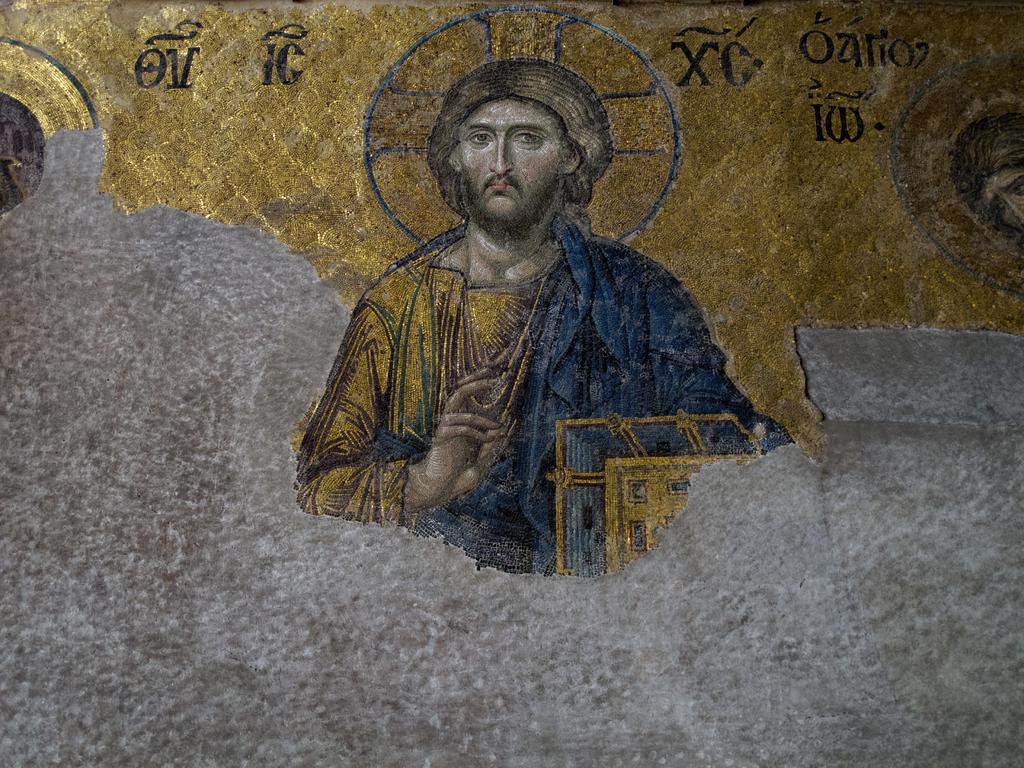What is in the foreground of the image? There is a model of a person in the foreground of the image. What is the model holding in its hand? The model is holding a book in its hand. Where is the model located? The model is on a wall. What can be seen on the wall in the top part of the image? There is gold paint on the wall in the top part of the image. Can you describe the wave pattern on the model's clothing in the image? There is no wave pattern mentioned on the model's clothing in the image. The provided facts only mention the model holding a book and being on a wall with gold paint on the top part. 